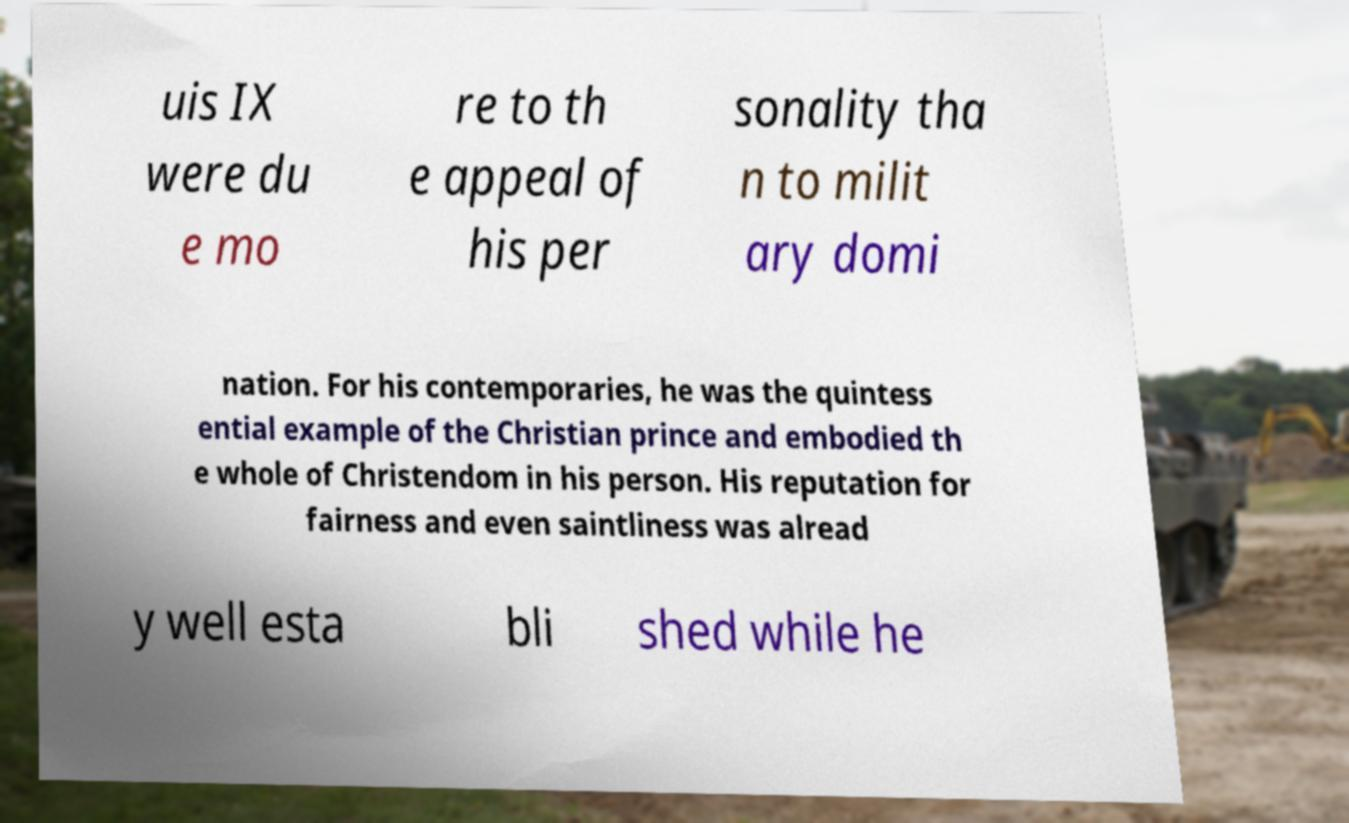I need the written content from this picture converted into text. Can you do that? uis IX were du e mo re to th e appeal of his per sonality tha n to milit ary domi nation. For his contemporaries, he was the quintess ential example of the Christian prince and embodied th e whole of Christendom in his person. His reputation for fairness and even saintliness was alread y well esta bli shed while he 